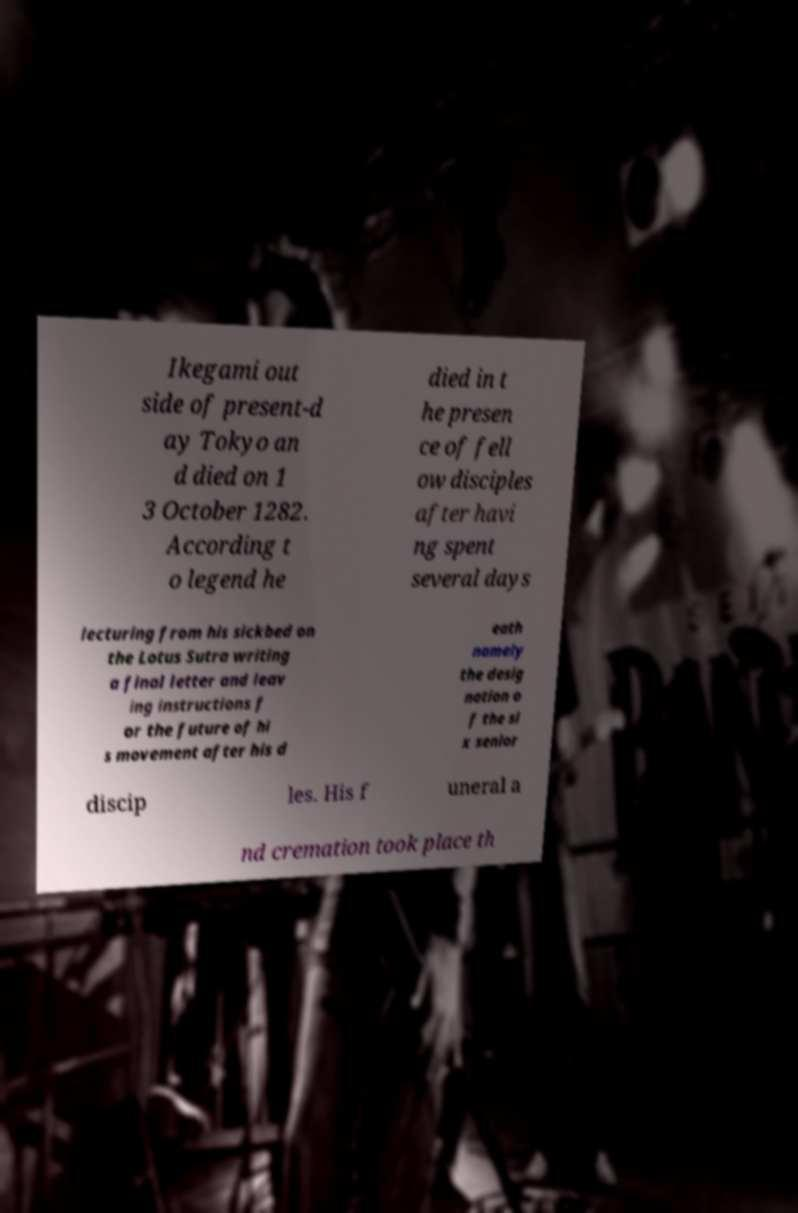What messages or text are displayed in this image? I need them in a readable, typed format. Ikegami out side of present-d ay Tokyo an d died on 1 3 October 1282. According t o legend he died in t he presen ce of fell ow disciples after havi ng spent several days lecturing from his sickbed on the Lotus Sutra writing a final letter and leav ing instructions f or the future of hi s movement after his d eath namely the desig nation o f the si x senior discip les. His f uneral a nd cremation took place th 